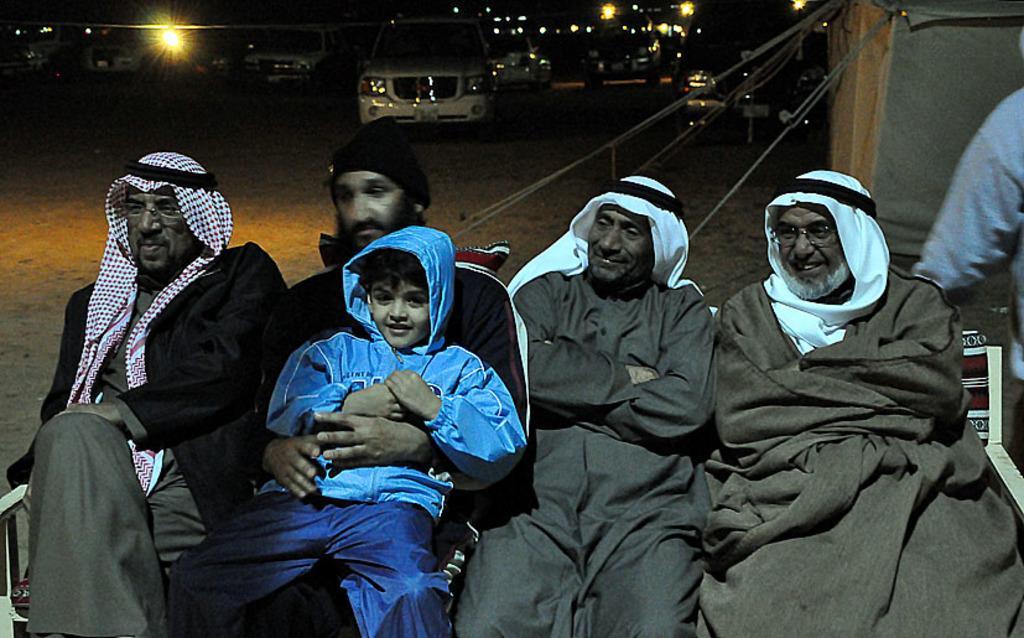Can you describe this image briefly? At the bottom of this image, there are four persons, smiling and sitting on a bench. One of them is a holding a boy who is in a blue color jacket. On the right side, there is another person. In the background, there are vehicles on the road, there are lights and a building. And the background is dark in color. 